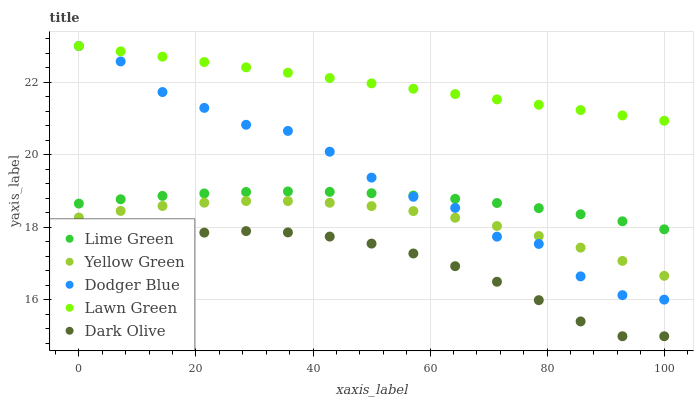Does Dark Olive have the minimum area under the curve?
Answer yes or no. Yes. Does Lawn Green have the maximum area under the curve?
Answer yes or no. Yes. Does Lime Green have the minimum area under the curve?
Answer yes or no. No. Does Lime Green have the maximum area under the curve?
Answer yes or no. No. Is Lawn Green the smoothest?
Answer yes or no. Yes. Is Dodger Blue the roughest?
Answer yes or no. Yes. Is Dark Olive the smoothest?
Answer yes or no. No. Is Dark Olive the roughest?
Answer yes or no. No. Does Dark Olive have the lowest value?
Answer yes or no. Yes. Does Lime Green have the lowest value?
Answer yes or no. No. Does Lawn Green have the highest value?
Answer yes or no. Yes. Does Lime Green have the highest value?
Answer yes or no. No. Is Dark Olive less than Lawn Green?
Answer yes or no. Yes. Is Lawn Green greater than Yellow Green?
Answer yes or no. Yes. Does Dodger Blue intersect Lime Green?
Answer yes or no. Yes. Is Dodger Blue less than Lime Green?
Answer yes or no. No. Is Dodger Blue greater than Lime Green?
Answer yes or no. No. Does Dark Olive intersect Lawn Green?
Answer yes or no. No. 